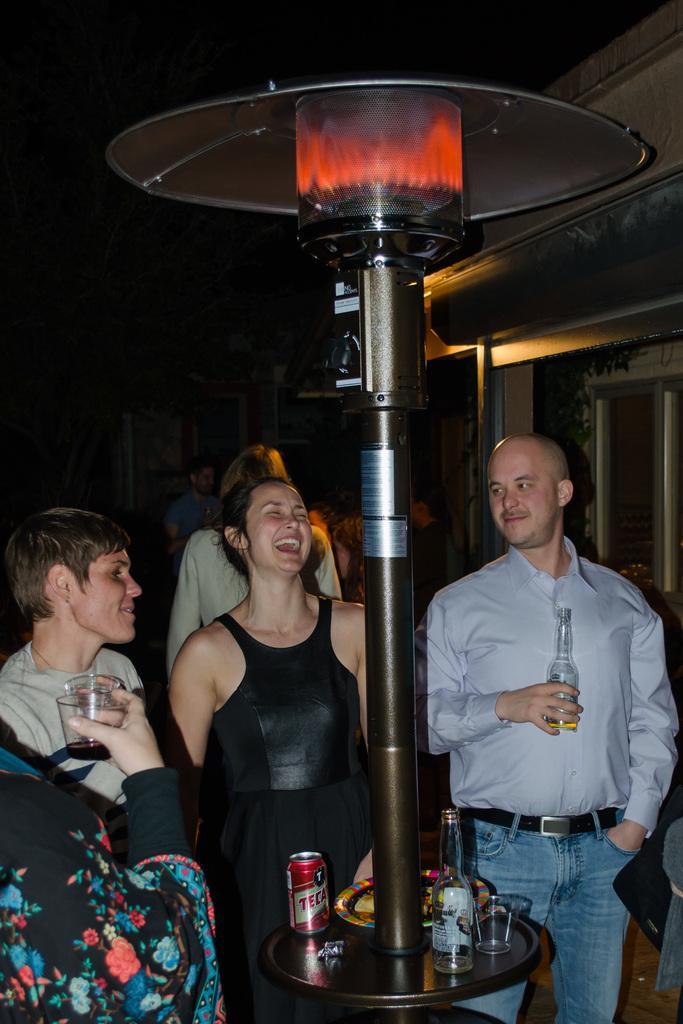Describe this image in one or two sentences. In this image I can see group of people standing. In front the person is wearing white and blue color dress and the person is holding the bottle. In front I can see few bottles, glasses on the black color surface and I can see few lights. 